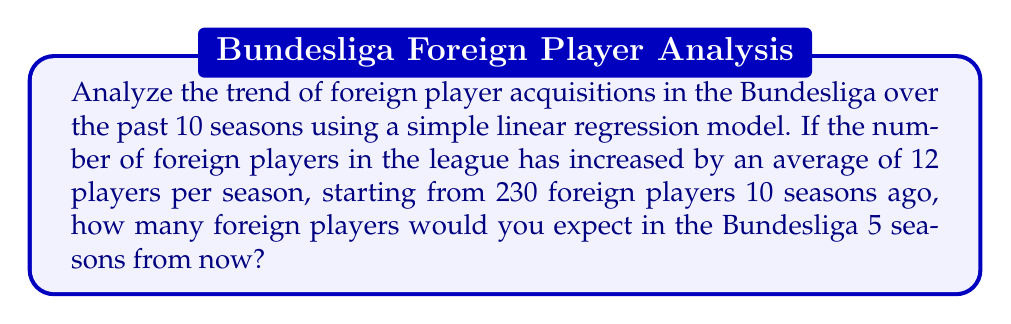Could you help me with this problem? Let's approach this step-by-step using a simple linear regression model:

1) Let $t$ represent the number of seasons, with $t=0$ being 10 seasons ago, and $y$ represent the number of foreign players.

2) The linear model is given by:
   $y = \beta_0 + \beta_1t$

   Where:
   $\beta_0$ is the y-intercept (initial number of foreign players)
   $\beta_1$ is the slope (average increase per season)

3) From the given information:
   $\beta_0 = 230$ (initial number 10 seasons ago)
   $\beta_1 = 12$ (average increase per season)

4) So our model is:
   $y = 230 + 12t$

5) We want to predict 5 seasons from now. Since our $t=0$ is 10 seasons ago, 5 seasons from now would be $t=15$.

6) Plugging in $t=15$:
   $y = 230 + 12(15) = 230 + 180 = 410$

Therefore, based on this simple linear trend, we would expect 410 foreign players in the Bundesliga 5 seasons from now.
Answer: 410 foreign players 